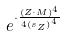<formula> <loc_0><loc_0><loc_500><loc_500>e ^ { \cdot \frac { ( Z \cdot M ) ^ { 4 } } { 4 { ( s _ { Z } ) } ^ { 4 } } }</formula> 